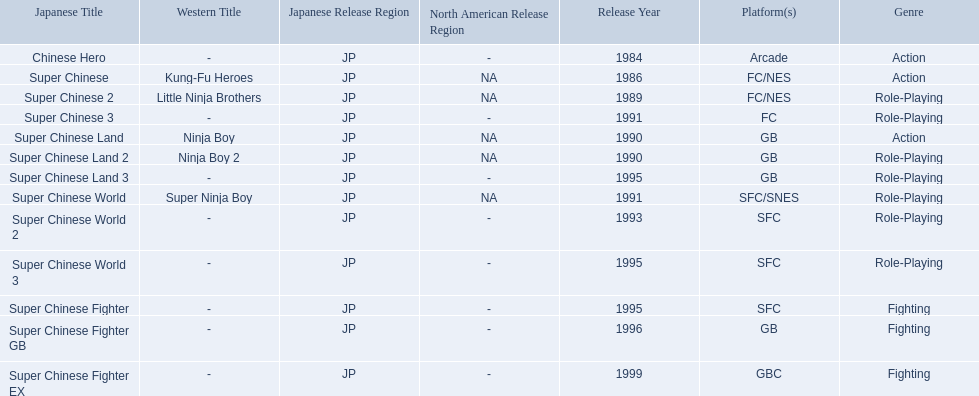Which titles were released in north america? Super Chinese, Super Chinese 2, Super Chinese Land, Super Chinese Land 2, Super Chinese World. Of those, which had the least releases? Super Chinese World. 